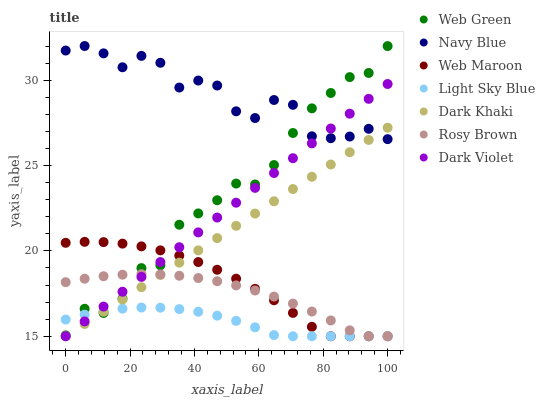Does Light Sky Blue have the minimum area under the curve?
Answer yes or no. Yes. Does Navy Blue have the maximum area under the curve?
Answer yes or no. Yes. Does Rosy Brown have the minimum area under the curve?
Answer yes or no. No. Does Rosy Brown have the maximum area under the curve?
Answer yes or no. No. Is Dark Khaki the smoothest?
Answer yes or no. Yes. Is Navy Blue the roughest?
Answer yes or no. Yes. Is Rosy Brown the smoothest?
Answer yes or no. No. Is Rosy Brown the roughest?
Answer yes or no. No. Does Rosy Brown have the lowest value?
Answer yes or no. Yes. Does Web Green have the lowest value?
Answer yes or no. No. Does Navy Blue have the highest value?
Answer yes or no. Yes. Does Rosy Brown have the highest value?
Answer yes or no. No. Is Light Sky Blue less than Navy Blue?
Answer yes or no. Yes. Is Navy Blue greater than Rosy Brown?
Answer yes or no. Yes. Does Dark Khaki intersect Navy Blue?
Answer yes or no. Yes. Is Dark Khaki less than Navy Blue?
Answer yes or no. No. Is Dark Khaki greater than Navy Blue?
Answer yes or no. No. Does Light Sky Blue intersect Navy Blue?
Answer yes or no. No. 